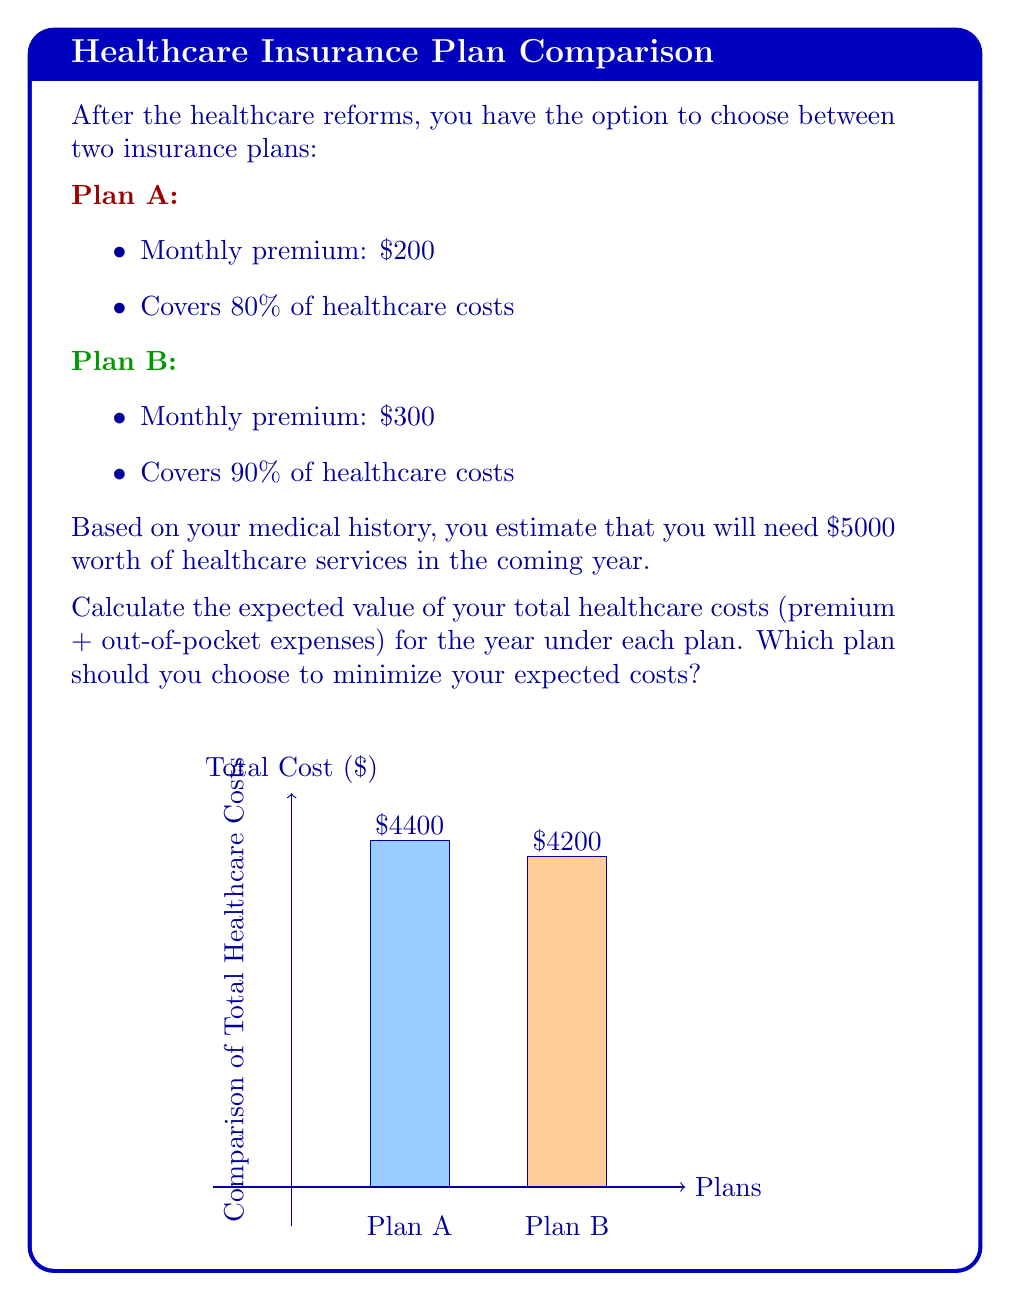Show me your answer to this math problem. Let's calculate the expected value of healthcare costs for each plan:

1. Plan A:
   - Annual premium: $200 × 12 months = $2400
   - Expected out-of-pocket expenses: 20% of $5000 = $1000
   - Total expected cost: $2400 + $1000 = $3400

2. Plan B:
   - Annual premium: $300 × 12 months = $3600
   - Expected out-of-pocket expenses: 10% of $5000 = $500
   - Total expected cost: $3600 + $500 = $4100

The expected value (EV) of healthcare costs is calculated using the formula:

$$ EV = \text{Annual Premium} + \text{Expected Out-of-Pocket Expenses} $$

For Plan A:
$$ EV_A = 2400 + 1000 = 3400 $$

For Plan B:
$$ EV_B = 3600 + 500 = 4100 $$

Comparing the two plans:
$$ EV_A < EV_B $$
$$ 3400 < 4100 $$

Therefore, Plan A has a lower expected value of healthcare costs for the year.
Answer: Plan A: $3400; Plan B: $4100. Choose Plan A to minimize expected costs. 